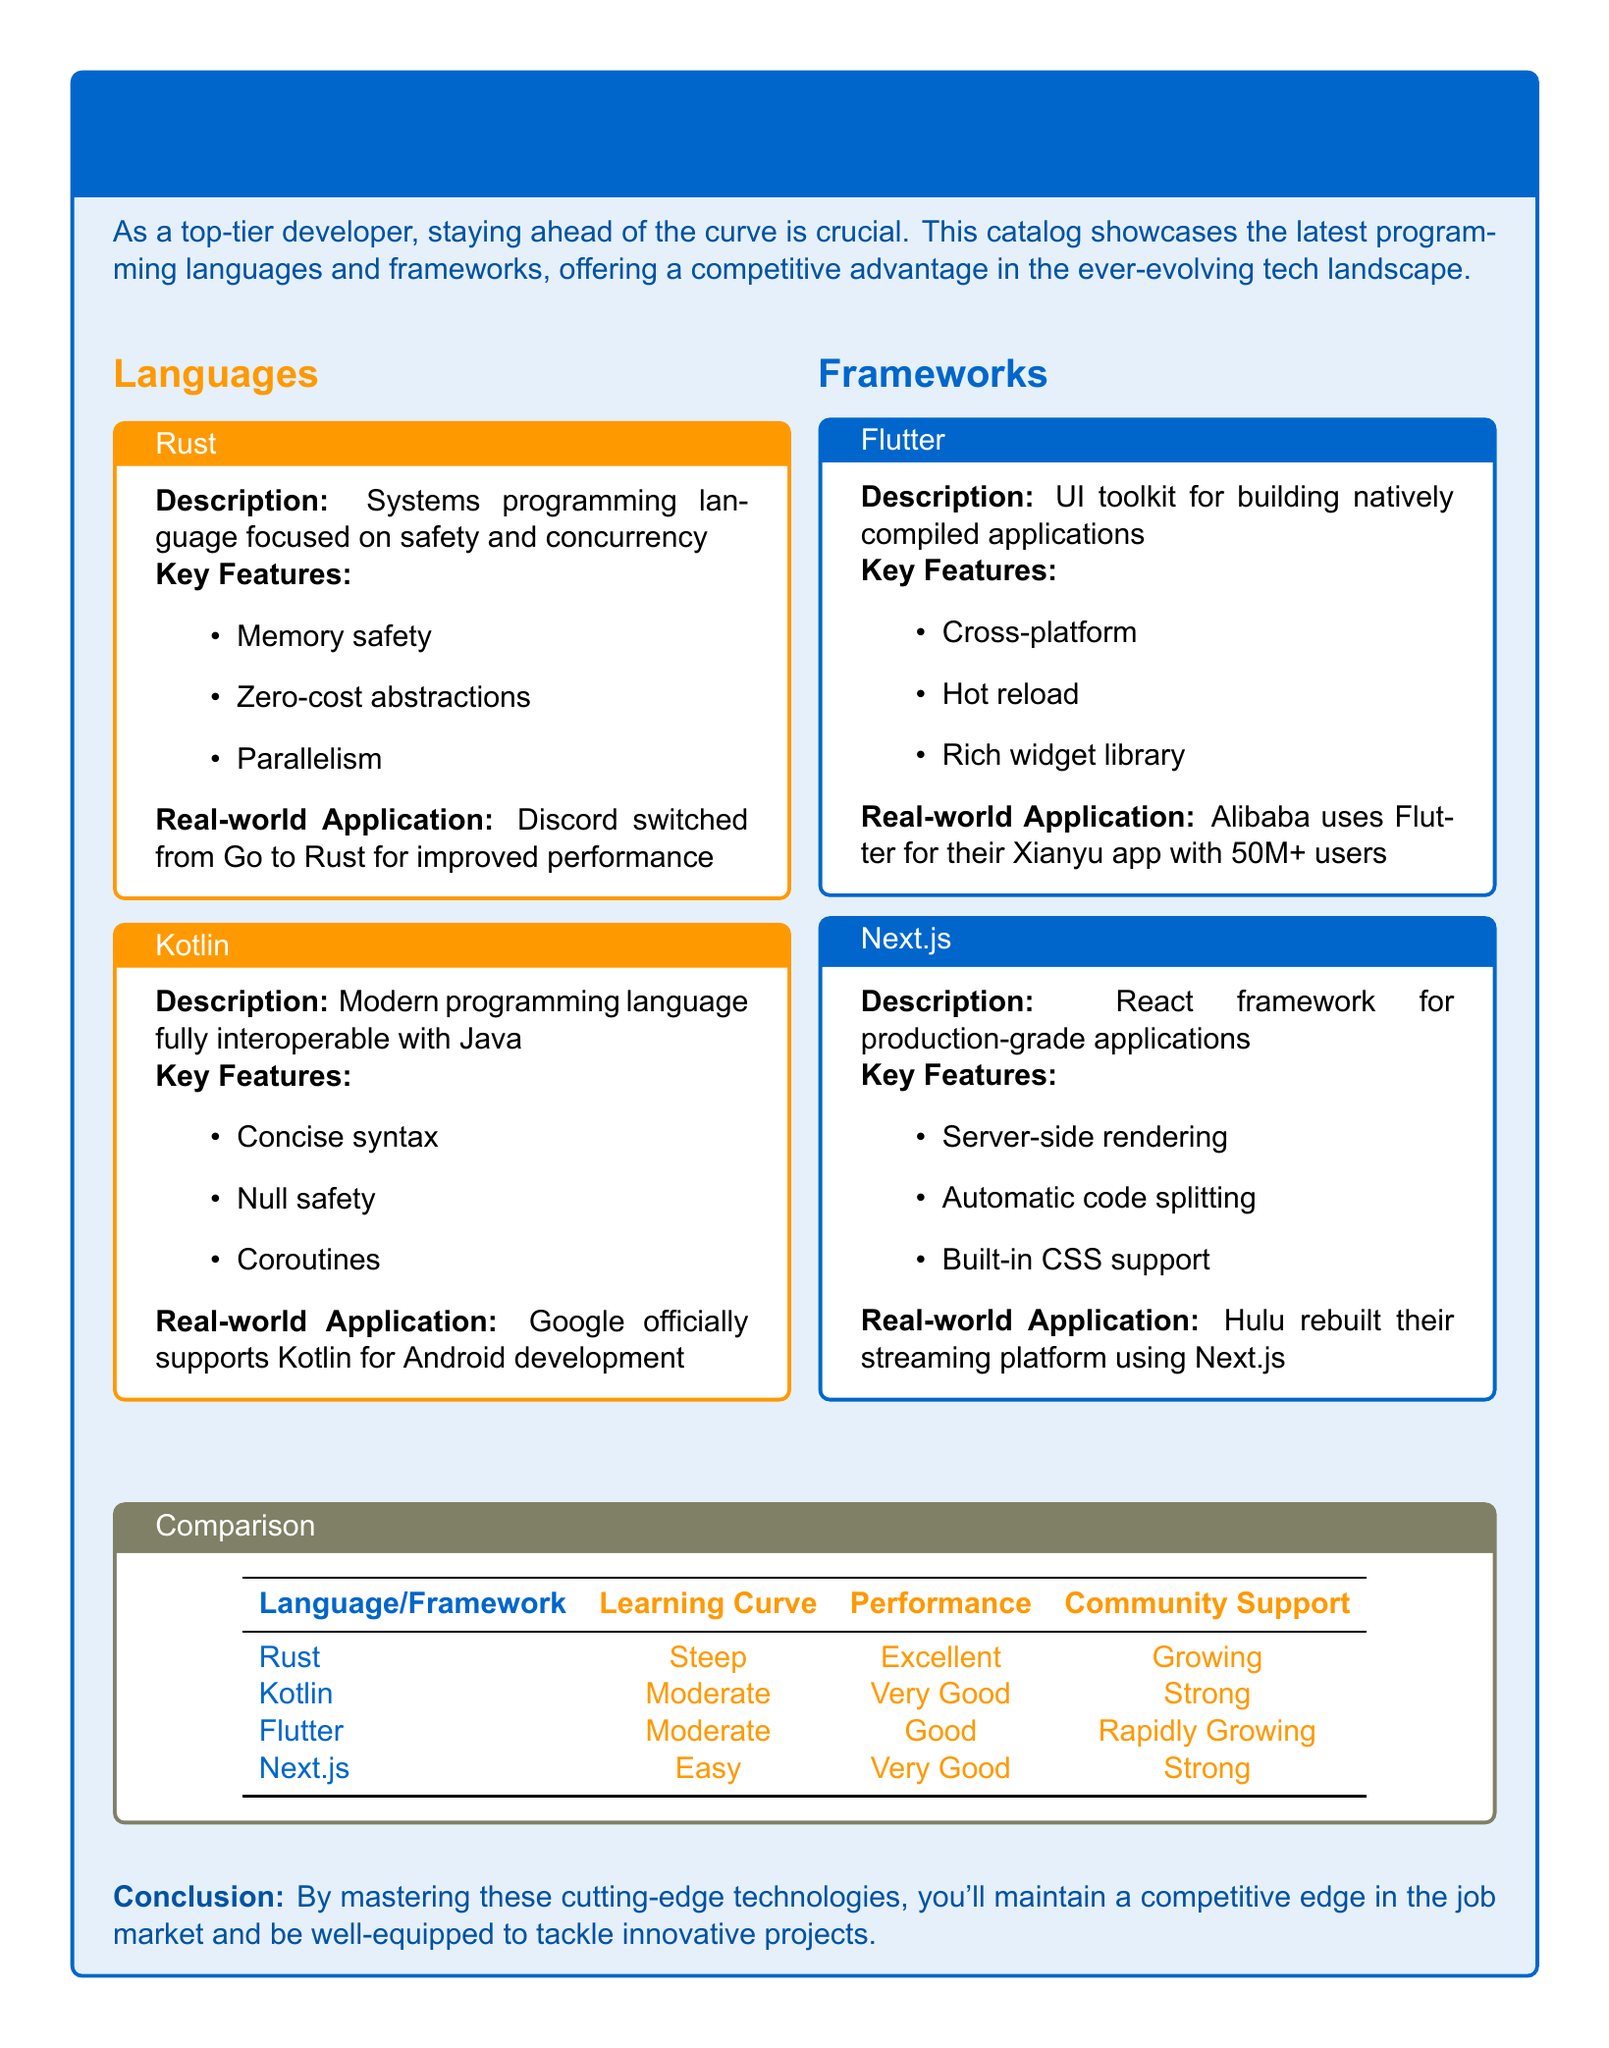What is the name of the catalog? The document title mentions the catalog as "Cutting-Edge Programming Languages and Frameworks: A Competitive Edge Catalog."
Answer: Cutting-Edge Programming Languages and Frameworks: A Competitive Edge Catalog What language focuses on safety and concurrency? The document describes Rust as a systems programming language focused on safety and concurrency.
Answer: Rust Which framework has a rich widget library? The description of Flutter highlights that it has a rich widget library as one of its key features.
Answer: Flutter What is Google's stance on Kotlin? The real-world application section states that Google officially supports Kotlin for Android development.
Answer: Officially supports How many users does Alibaba's Xianyu app have? The document states that Alibaba uses Flutter for their Xianyu app with over 50 million users.
Answer: 50M+ Which language has a steep learning curve? The comparison table shows that Rust is listed with a steep learning curve.
Answer: Steep Which framework is known for server-side rendering? The document states that Next.js is a React framework known for server-side rendering.
Answer: Next.js What type of application is Flutter used for? According to the document, Flutter is a UI toolkit for building natively compiled applications.
Answer: Natively compiled applications Which language has very good performance? The comparison table indicates that Kotlin has very good performance.
Answer: Very Good 